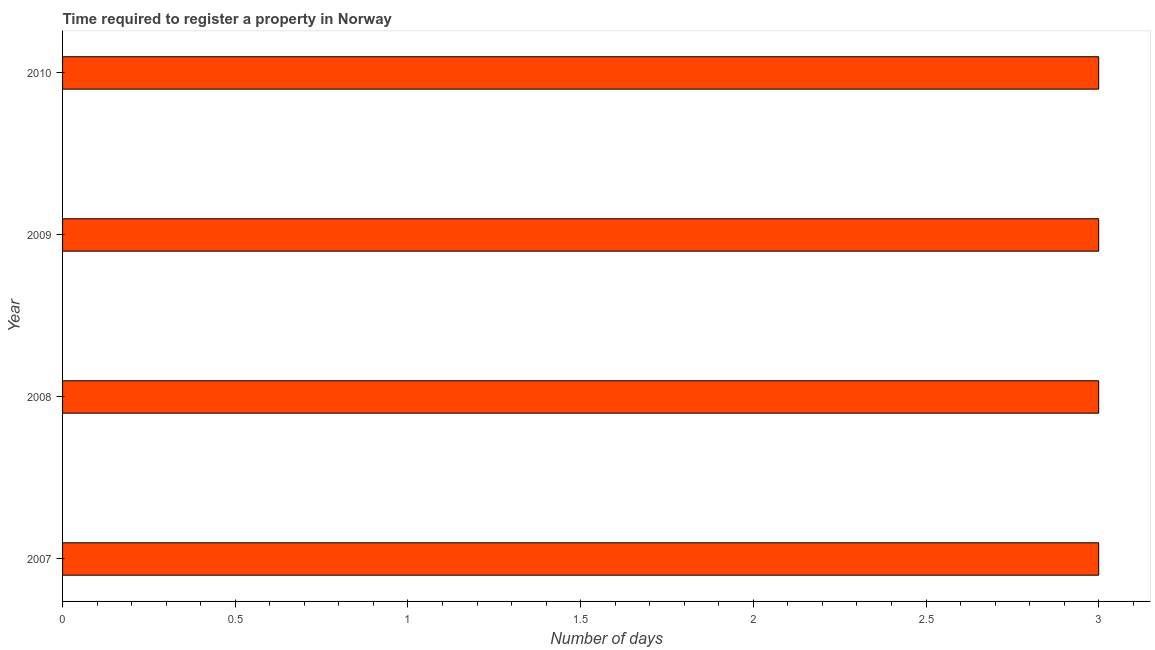Does the graph contain grids?
Your answer should be very brief. No. What is the title of the graph?
Offer a terse response. Time required to register a property in Norway. What is the label or title of the X-axis?
Offer a very short reply. Number of days. Across all years, what is the maximum number of days required to register property?
Ensure brevity in your answer.  3. In which year was the number of days required to register property maximum?
Provide a short and direct response. 2007. In which year was the number of days required to register property minimum?
Ensure brevity in your answer.  2007. What is the average number of days required to register property per year?
Keep it short and to the point. 3. What is the median number of days required to register property?
Your answer should be very brief. 3. In how many years, is the number of days required to register property greater than 2.8 days?
Your answer should be very brief. 4. Do a majority of the years between 2008 and 2010 (inclusive) have number of days required to register property greater than 0.4 days?
Make the answer very short. Yes. Is the number of days required to register property in 2008 less than that in 2009?
Your answer should be very brief. No. What is the difference between the highest and the lowest number of days required to register property?
Give a very brief answer. 0. In how many years, is the number of days required to register property greater than the average number of days required to register property taken over all years?
Provide a short and direct response. 0. How many years are there in the graph?
Your answer should be compact. 4. Are the values on the major ticks of X-axis written in scientific E-notation?
Your response must be concise. No. What is the Number of days of 2008?
Give a very brief answer. 3. What is the Number of days of 2009?
Give a very brief answer. 3. What is the difference between the Number of days in 2007 and 2009?
Your response must be concise. 0. What is the difference between the Number of days in 2008 and 2009?
Your answer should be compact. 0. What is the ratio of the Number of days in 2007 to that in 2008?
Your answer should be compact. 1. What is the ratio of the Number of days in 2007 to that in 2009?
Offer a terse response. 1. What is the ratio of the Number of days in 2008 to that in 2010?
Ensure brevity in your answer.  1. 